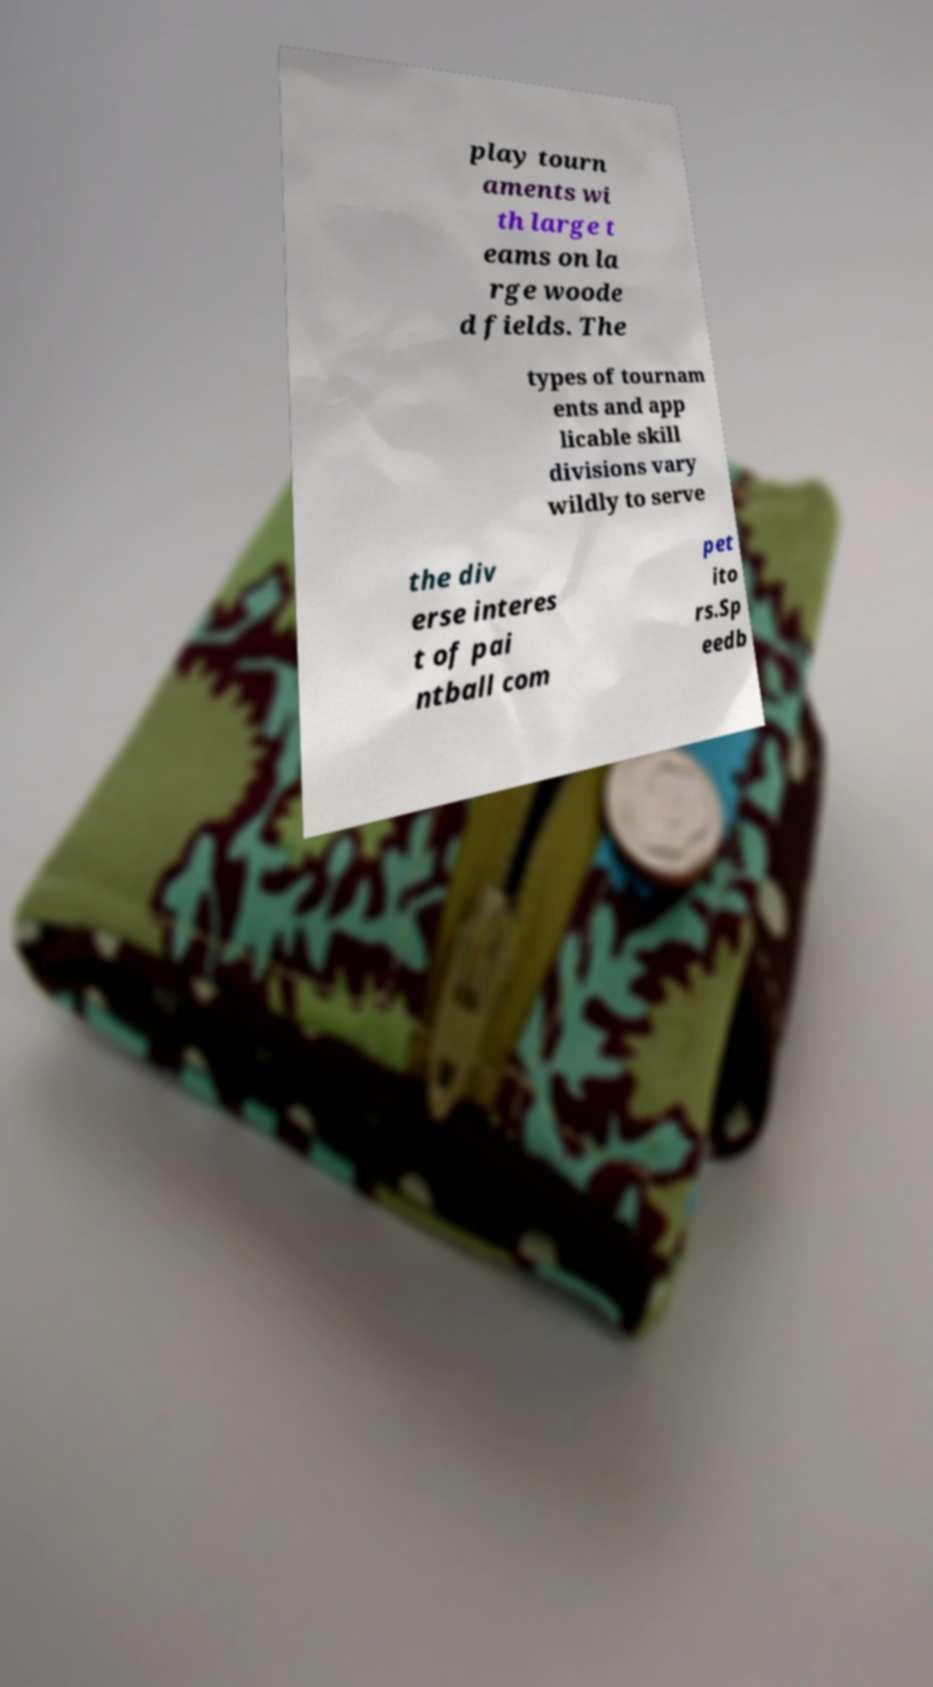Could you extract and type out the text from this image? play tourn aments wi th large t eams on la rge woode d fields. The types of tournam ents and app licable skill divisions vary wildly to serve the div erse interes t of pai ntball com pet ito rs.Sp eedb 